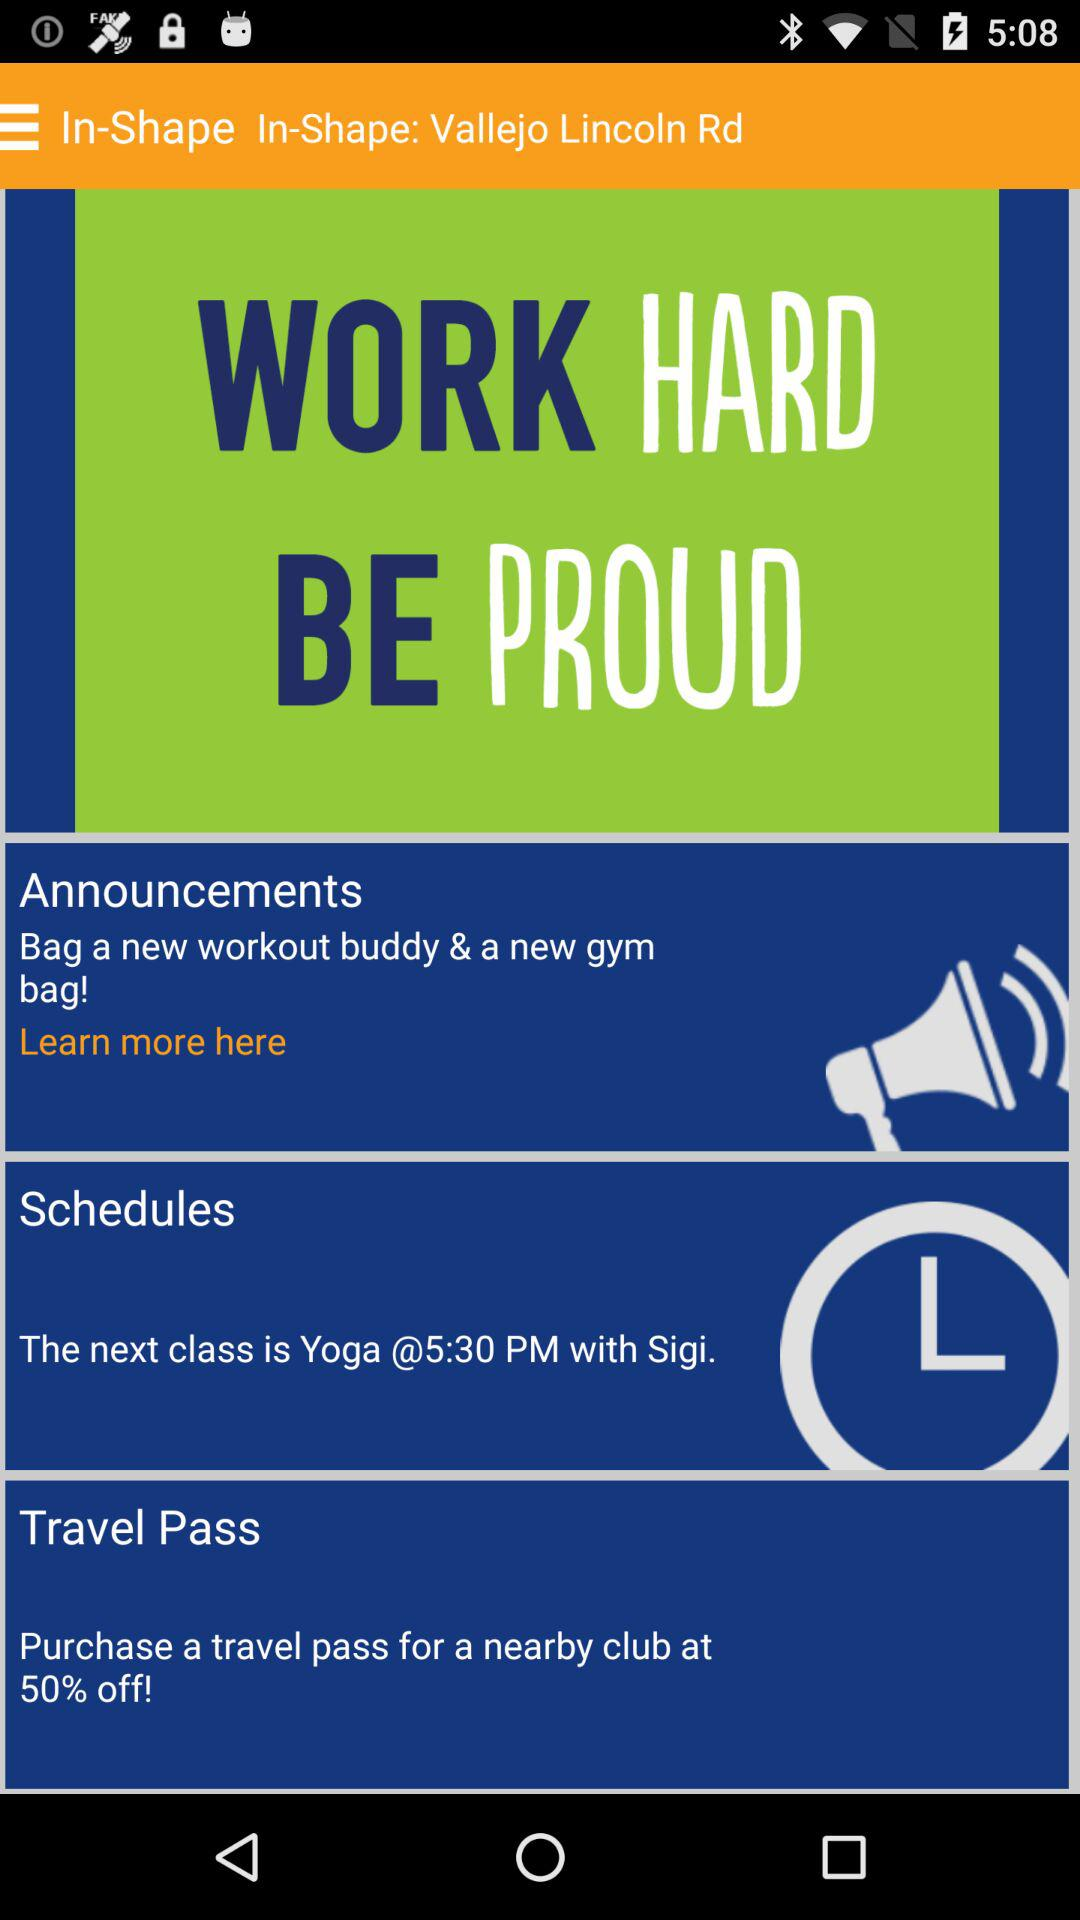Who is in charge of the yoga class? In charge of the yoga class is Sigi. 